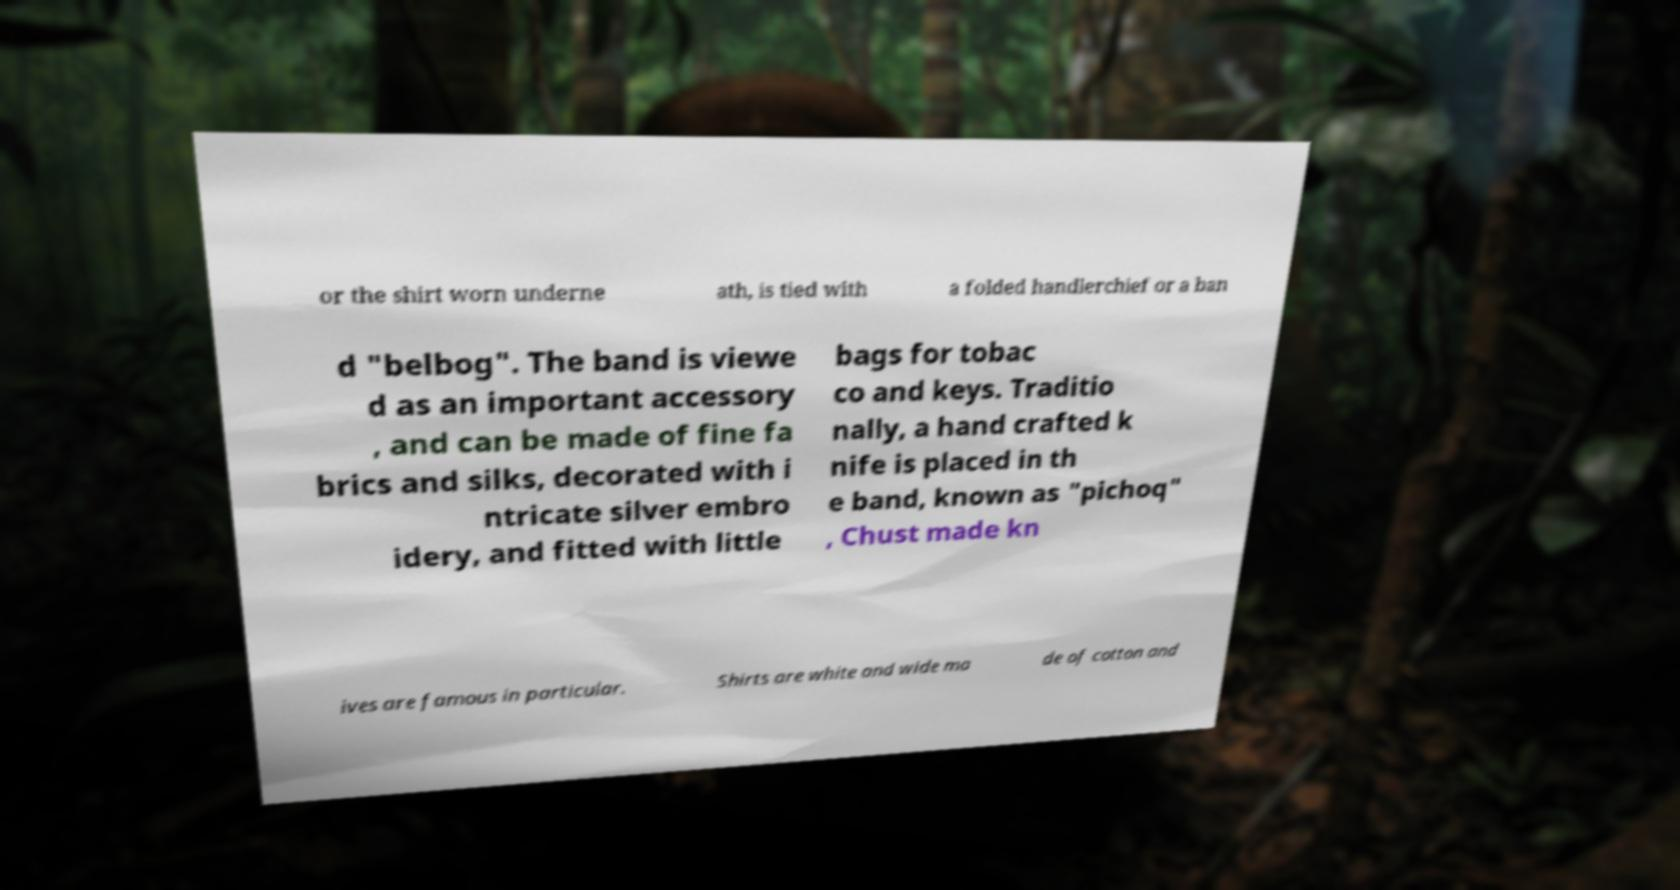Can you read and provide the text displayed in the image?This photo seems to have some interesting text. Can you extract and type it out for me? or the shirt worn underne ath, is tied with a folded handlerchief or a ban d "belbog". The band is viewe d as an important accessory , and can be made of fine fa brics and silks, decorated with i ntricate silver embro idery, and fitted with little bags for tobac co and keys. Traditio nally, a hand crafted k nife is placed in th e band, known as "pichoq" , Chust made kn ives are famous in particular. Shirts are white and wide ma de of cotton and 